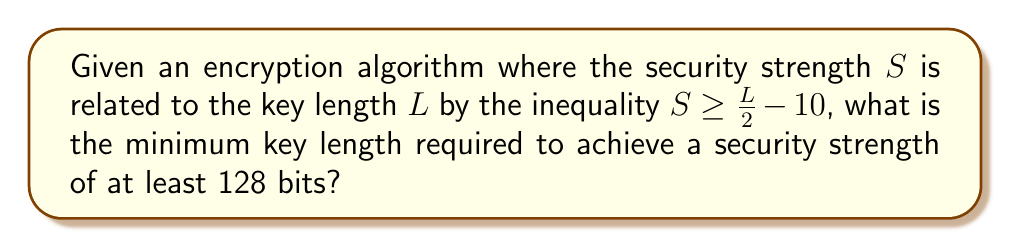Can you solve this math problem? To solve this problem, we need to follow these steps:

1) We start with the given inequality:
   $S \geq \frac{L}{2} - 10$

2) We want a security strength of at least 128 bits, so we can replace $S$ with 128:
   $128 \geq \frac{L}{2} - 10$

3) Now, we solve this inequality for $L$:
   $128 + 10 \geq \frac{L}{2}$
   $138 \geq \frac{L}{2}$

4) Multiply both sides by 2:
   $276 \geq L$

5) Since $L$ represents key length, it must be a whole number. Therefore, the minimum value for $L$ that satisfies this inequality is the ceiling of 276.

6) The ceiling of 276 is 276 itself, as it's already a whole number.

Therefore, the minimum key length required is 276 bits.
Answer: 276 bits 